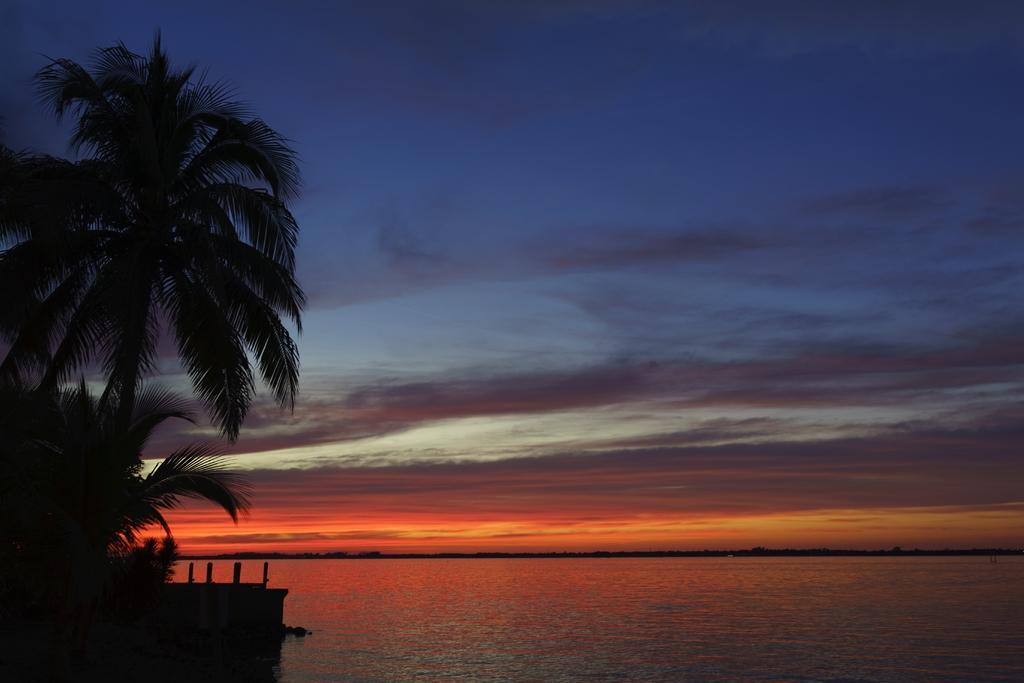Could you give a brief overview of what you see in this image? In this image, we can see water and some coconut trees and the sky. 